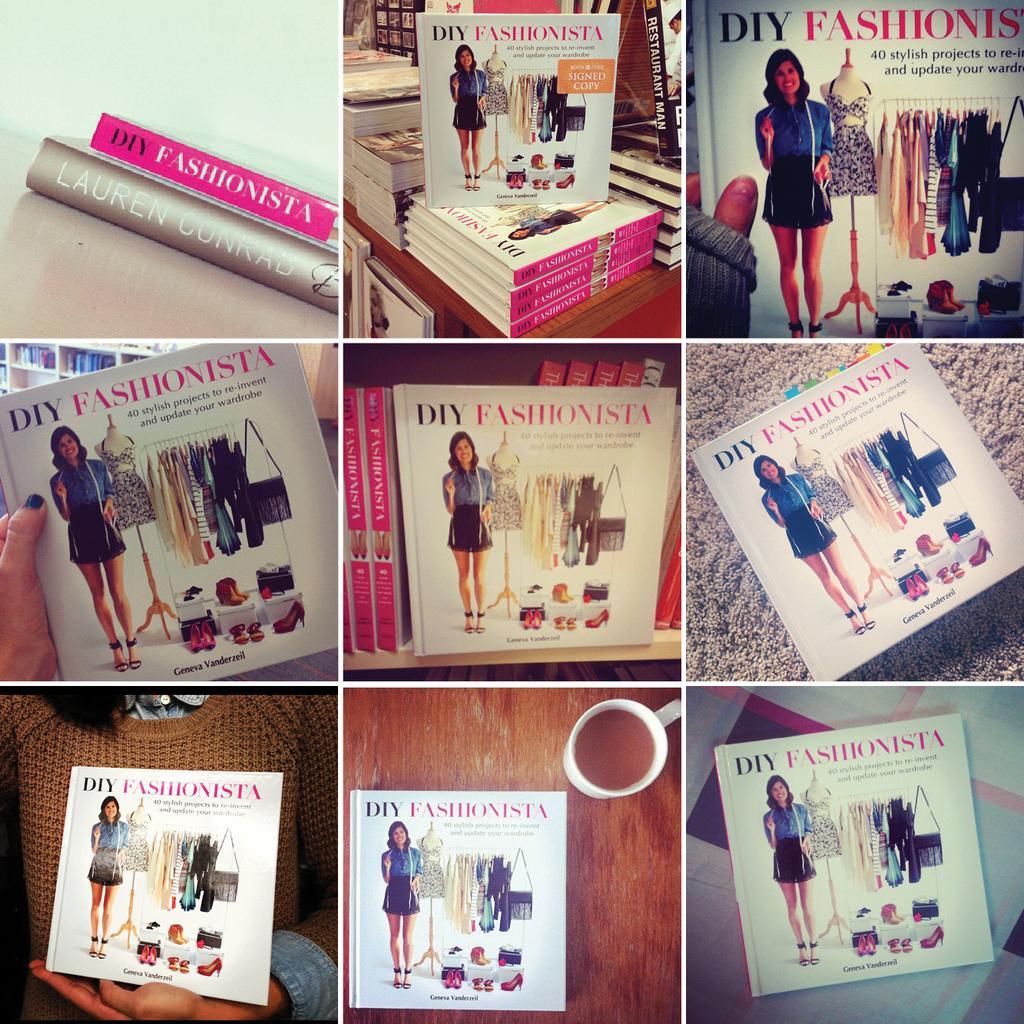Can you describe this image briefly? This is a collage picture. In this picture we can see the books, cup of tea on a wooden platform, people hands and we can see a book in the person hand. 